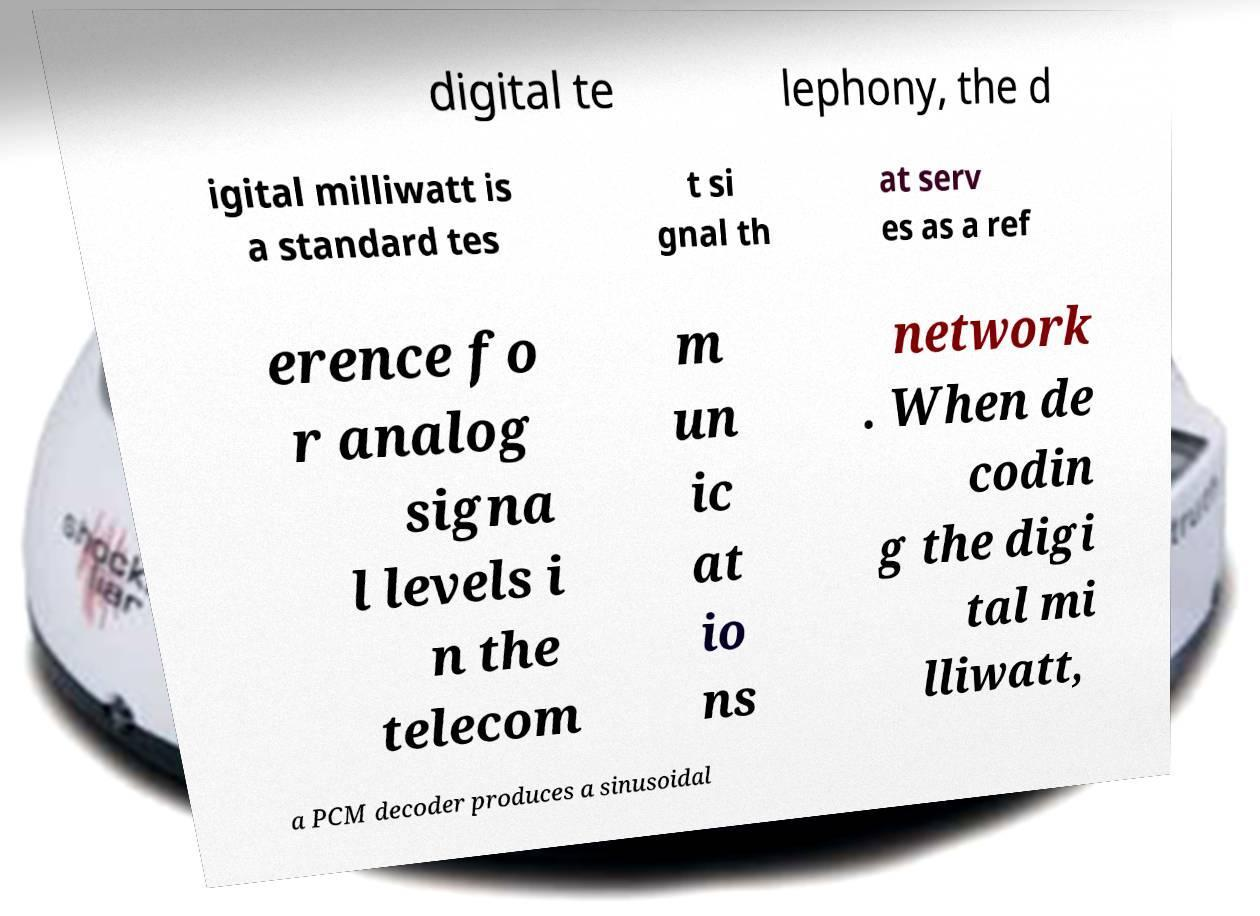Could you assist in decoding the text presented in this image and type it out clearly? digital te lephony, the d igital milliwatt is a standard tes t si gnal th at serv es as a ref erence fo r analog signa l levels i n the telecom m un ic at io ns network . When de codin g the digi tal mi lliwatt, a PCM decoder produces a sinusoidal 